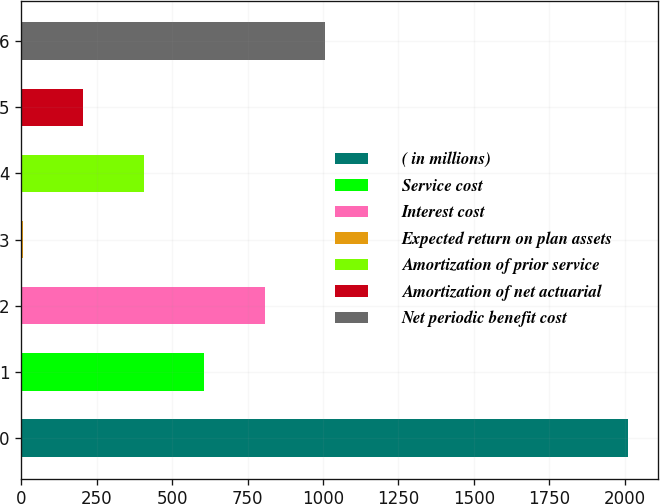Convert chart to OTSL. <chart><loc_0><loc_0><loc_500><loc_500><bar_chart><fcel>( in millions)<fcel>Service cost<fcel>Interest cost<fcel>Expected return on plan assets<fcel>Amortization of prior service<fcel>Amortization of net actuarial<fcel>Net periodic benefit cost<nl><fcel>2010<fcel>606.32<fcel>806.85<fcel>4.73<fcel>405.79<fcel>205.26<fcel>1007.38<nl></chart> 